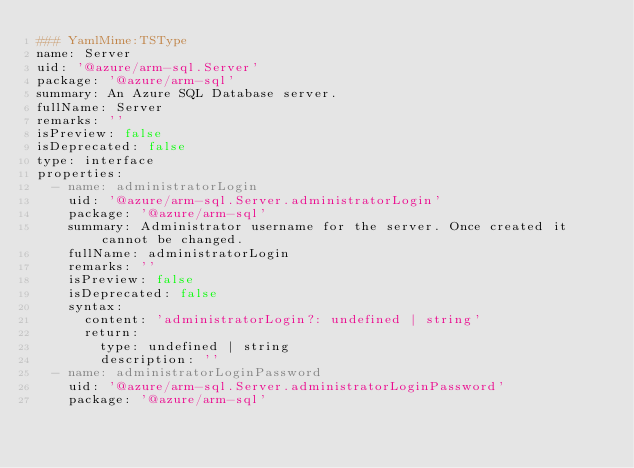Convert code to text. <code><loc_0><loc_0><loc_500><loc_500><_YAML_>### YamlMime:TSType
name: Server
uid: '@azure/arm-sql.Server'
package: '@azure/arm-sql'
summary: An Azure SQL Database server.
fullName: Server
remarks: ''
isPreview: false
isDeprecated: false
type: interface
properties:
  - name: administratorLogin
    uid: '@azure/arm-sql.Server.administratorLogin'
    package: '@azure/arm-sql'
    summary: Administrator username for the server. Once created it cannot be changed.
    fullName: administratorLogin
    remarks: ''
    isPreview: false
    isDeprecated: false
    syntax:
      content: 'administratorLogin?: undefined | string'
      return:
        type: undefined | string
        description: ''
  - name: administratorLoginPassword
    uid: '@azure/arm-sql.Server.administratorLoginPassword'
    package: '@azure/arm-sql'</code> 